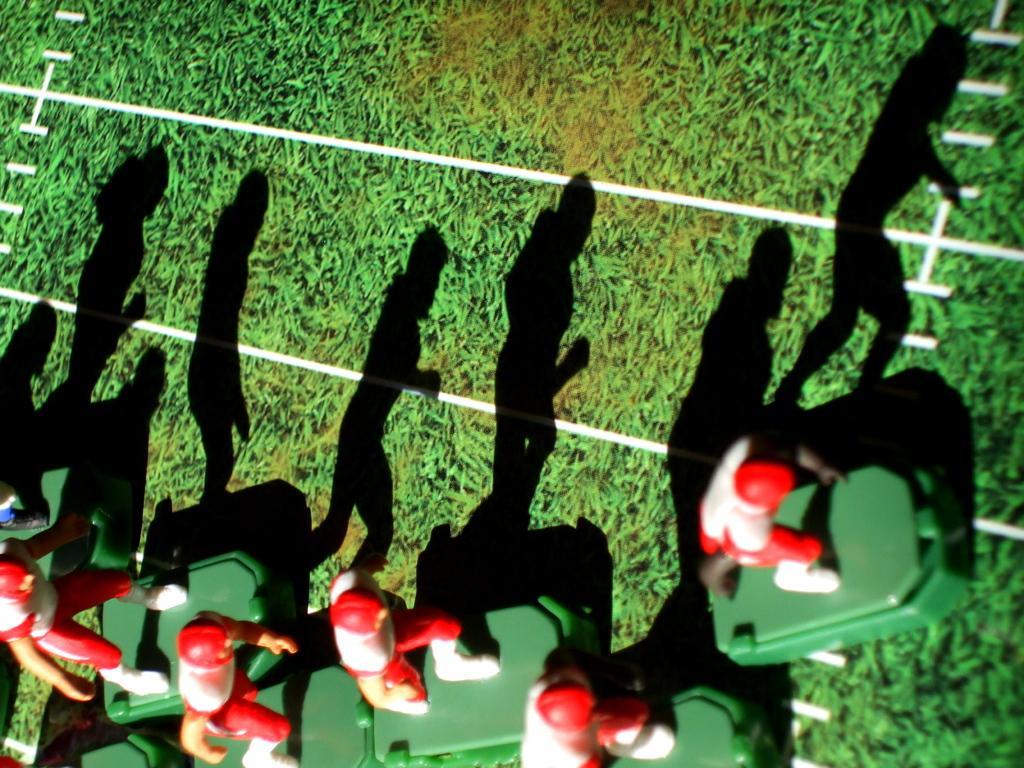In one or two sentences, can you explain what this image depicts? There are red and white color toys on a green surface. 